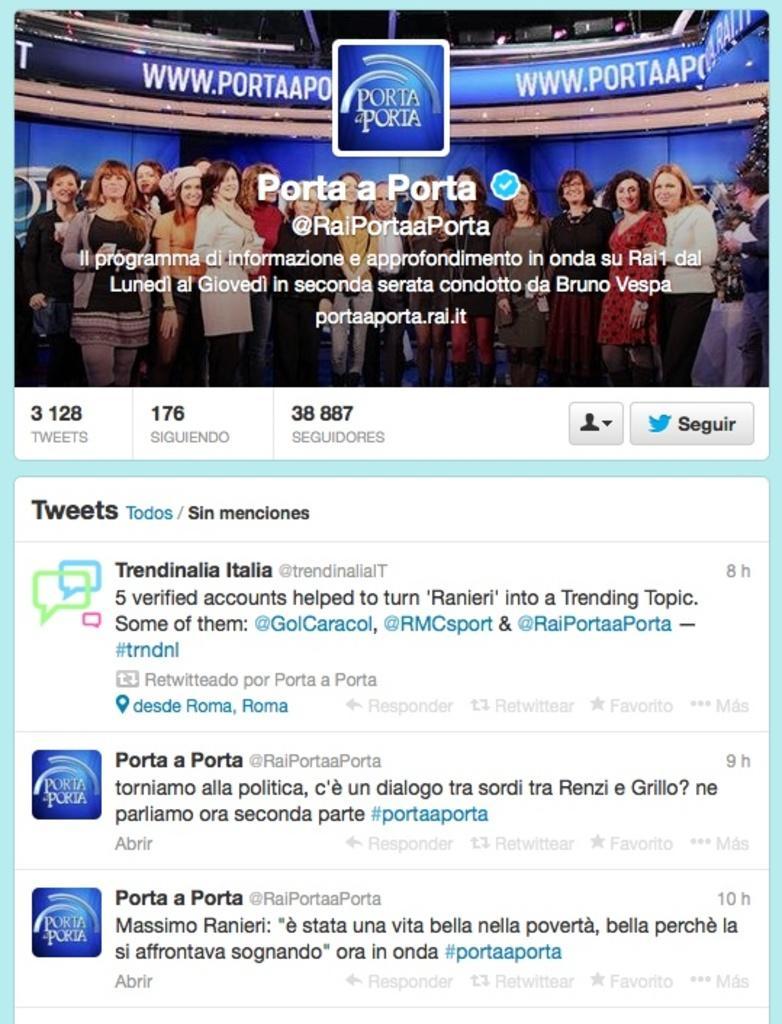How would you summarize this image in a sentence or two? In this image I can see the screenshot of the browser and in the top I can see the picture in which there are number of persons standing and in the background I can see the blue colored wall, a Christmas tree and a blue colored board. 